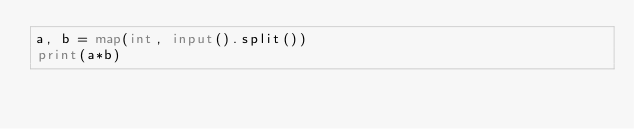<code> <loc_0><loc_0><loc_500><loc_500><_Python_>a, b = map(int, input().split())
print(a*b)</code> 